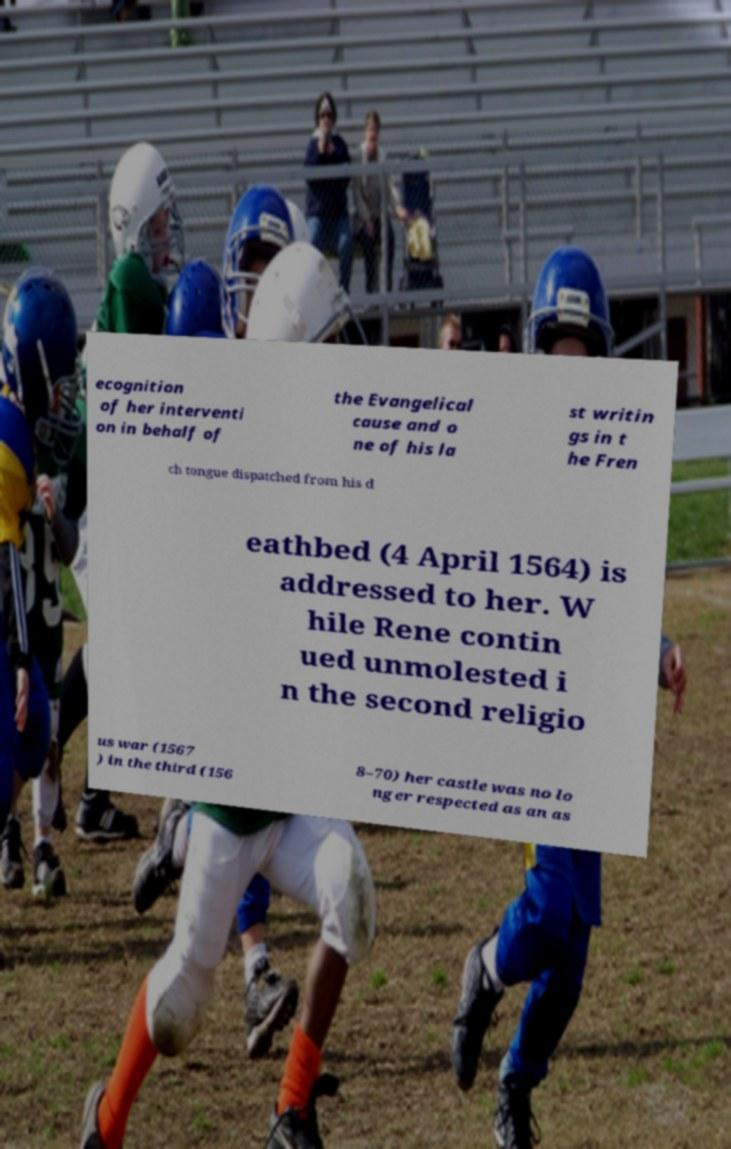What messages or text are displayed in this image? I need them in a readable, typed format. ecognition of her interventi on in behalf of the Evangelical cause and o ne of his la st writin gs in t he Fren ch tongue dispatched from his d eathbed (4 April 1564) is addressed to her. W hile Rene contin ued unmolested i n the second religio us war (1567 ) in the third (156 8–70) her castle was no lo nger respected as an as 